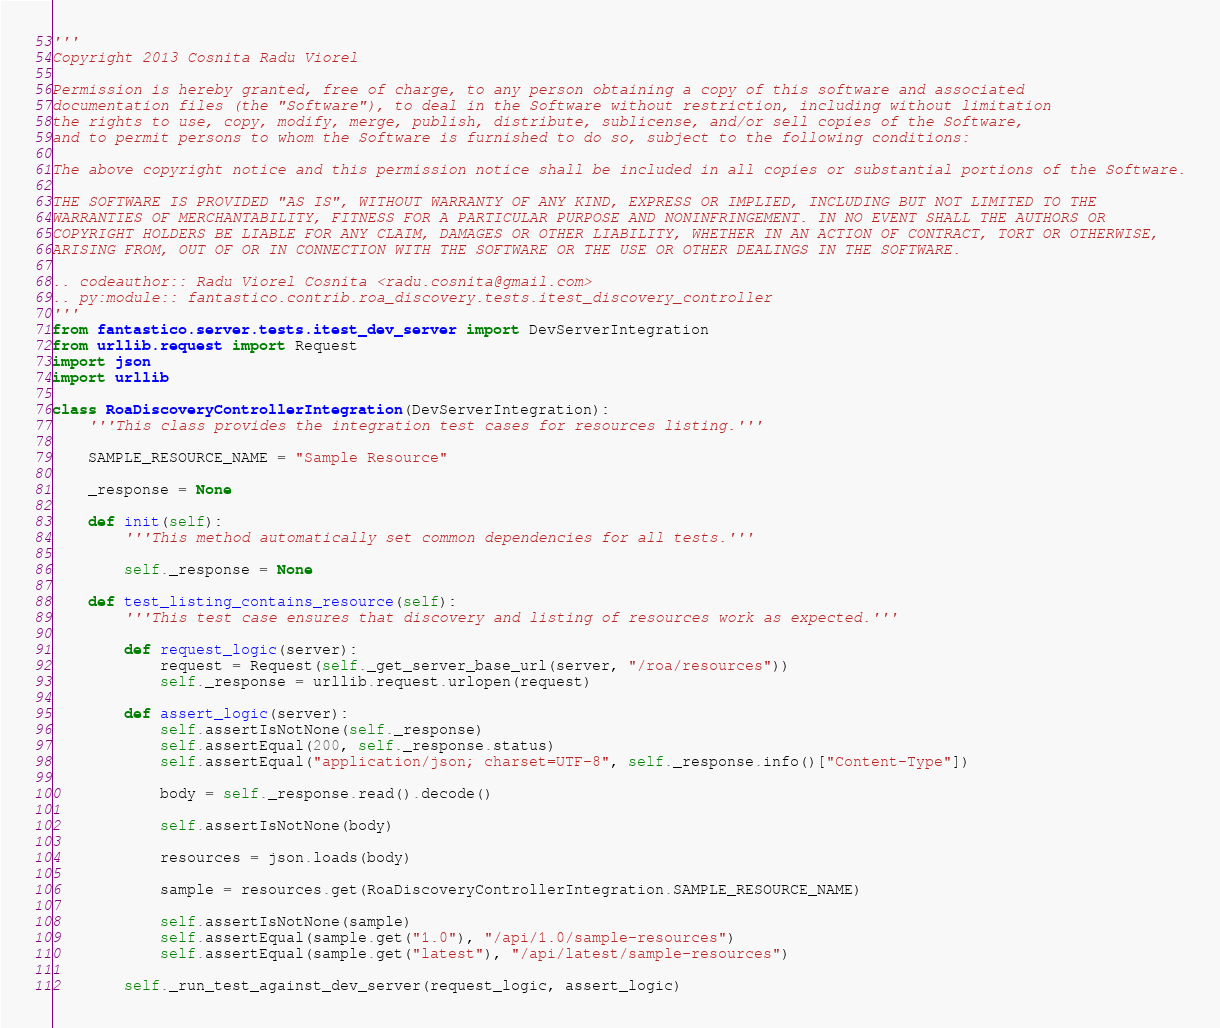<code> <loc_0><loc_0><loc_500><loc_500><_Python_>'''
Copyright 2013 Cosnita Radu Viorel

Permission is hereby granted, free of charge, to any person obtaining a copy of this software and associated
documentation files (the "Software"), to deal in the Software without restriction, including without limitation
the rights to use, copy, modify, merge, publish, distribute, sublicense, and/or sell copies of the Software,
and to permit persons to whom the Software is furnished to do so, subject to the following conditions:

The above copyright notice and this permission notice shall be included in all copies or substantial portions of the Software.

THE SOFTWARE IS PROVIDED "AS IS", WITHOUT WARRANTY OF ANY KIND, EXPRESS OR IMPLIED, INCLUDING BUT NOT LIMITED TO THE
WARRANTIES OF MERCHANTABILITY, FITNESS FOR A PARTICULAR PURPOSE AND NONINFRINGEMENT. IN NO EVENT SHALL THE AUTHORS OR
COPYRIGHT HOLDERS BE LIABLE FOR ANY CLAIM, DAMAGES OR OTHER LIABILITY, WHETHER IN AN ACTION OF CONTRACT, TORT OR OTHERWISE,
ARISING FROM, OUT OF OR IN CONNECTION WITH THE SOFTWARE OR THE USE OR OTHER DEALINGS IN THE SOFTWARE.

.. codeauthor:: Radu Viorel Cosnita <radu.cosnita@gmail.com>
.. py:module:: fantastico.contrib.roa_discovery.tests.itest_discovery_controller
'''
from fantastico.server.tests.itest_dev_server import DevServerIntegration
from urllib.request import Request
import json
import urllib

class RoaDiscoveryControllerIntegration(DevServerIntegration):
    '''This class provides the integration test cases for resources listing.'''

    SAMPLE_RESOURCE_NAME = "Sample Resource"

    _response = None

    def init(self):
        '''This method automatically set common dependencies for all tests.'''

        self._response = None

    def test_listing_contains_resource(self):
        '''This test case ensures that discovery and listing of resources work as expected.'''

        def request_logic(server):
            request = Request(self._get_server_base_url(server, "/roa/resources"))
            self._response = urllib.request.urlopen(request)

        def assert_logic(server):
            self.assertIsNotNone(self._response)
            self.assertEqual(200, self._response.status)
            self.assertEqual("application/json; charset=UTF-8", self._response.info()["Content-Type"])

            body = self._response.read().decode()

            self.assertIsNotNone(body)

            resources = json.loads(body)

            sample = resources.get(RoaDiscoveryControllerIntegration.SAMPLE_RESOURCE_NAME)

            self.assertIsNotNone(sample)
            self.assertEqual(sample.get("1.0"), "/api/1.0/sample-resources")
            self.assertEqual(sample.get("latest"), "/api/latest/sample-resources")

        self._run_test_against_dev_server(request_logic, assert_logic)
</code> 